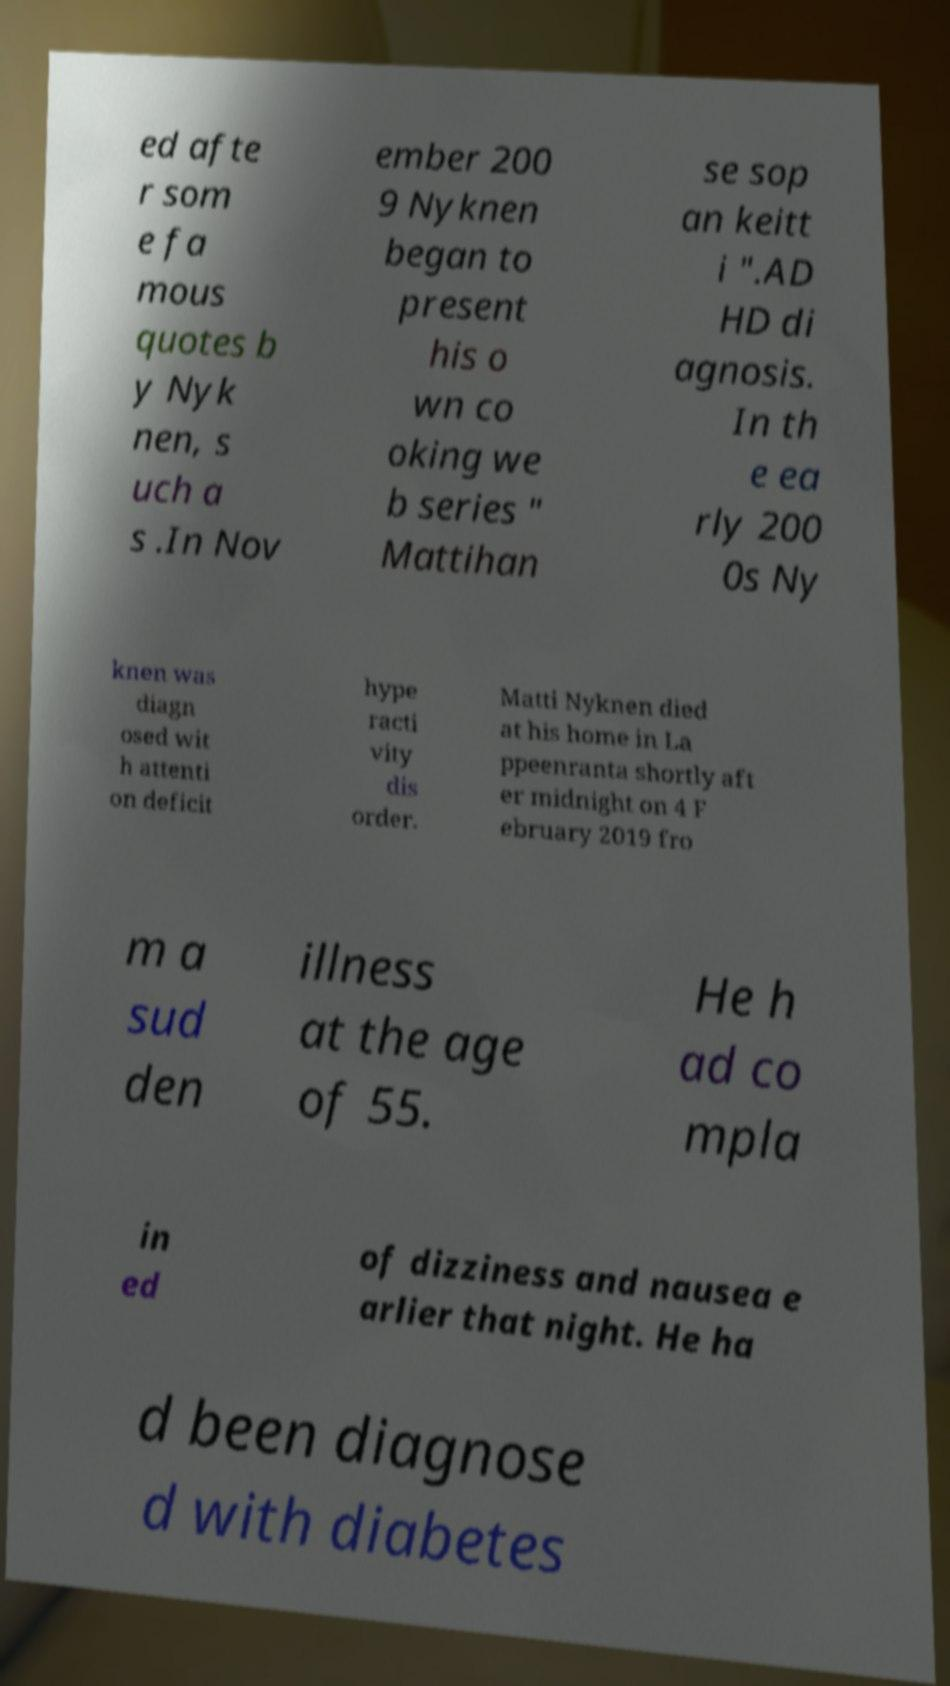Can you read and provide the text displayed in the image?This photo seems to have some interesting text. Can you extract and type it out for me? ed afte r som e fa mous quotes b y Nyk nen, s uch a s .In Nov ember 200 9 Nyknen began to present his o wn co oking we b series " Mattihan se sop an keitt i ".AD HD di agnosis. In th e ea rly 200 0s Ny knen was diagn osed wit h attenti on deficit hype racti vity dis order. Matti Nyknen died at his home in La ppeenranta shortly aft er midnight on 4 F ebruary 2019 fro m a sud den illness at the age of 55. He h ad co mpla in ed of dizziness and nausea e arlier that night. He ha d been diagnose d with diabetes 